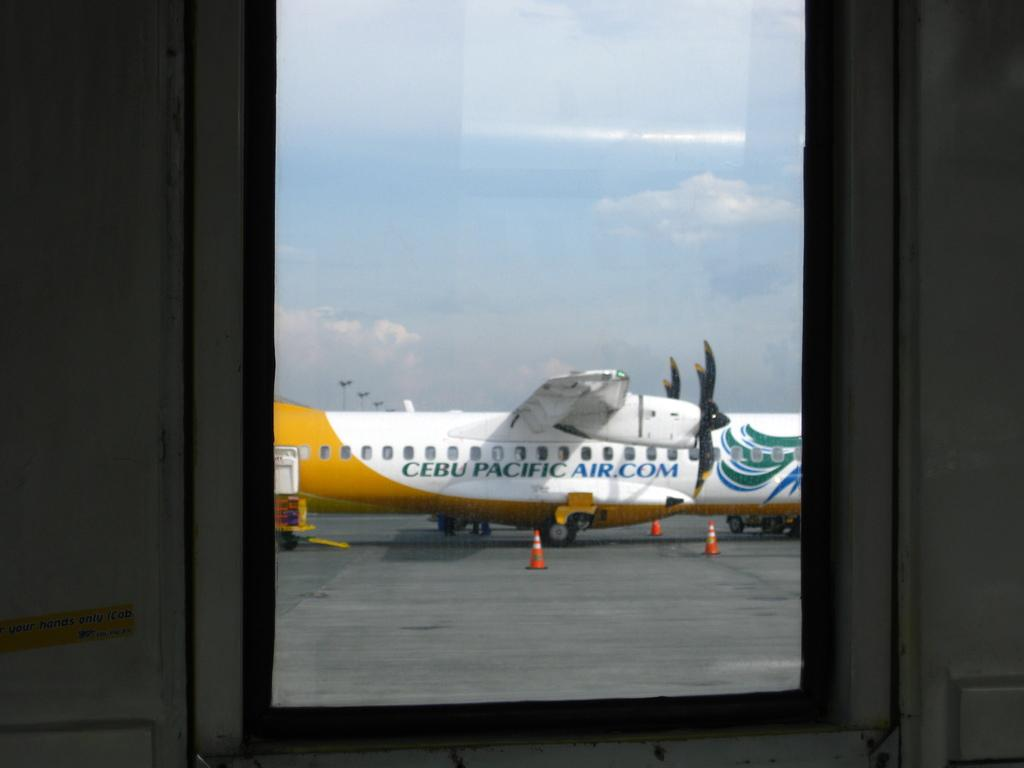What object is present in the image? There is a glass in the image. What is located outside the image? There is an airplane outside the image. What colors are the airplane? The airplane is white and yellow in color. What is visible at the top of the image? The sky is visible at the top of the image. What type of game is being played with the dirt in the image? There is no game or dirt present in the image. 